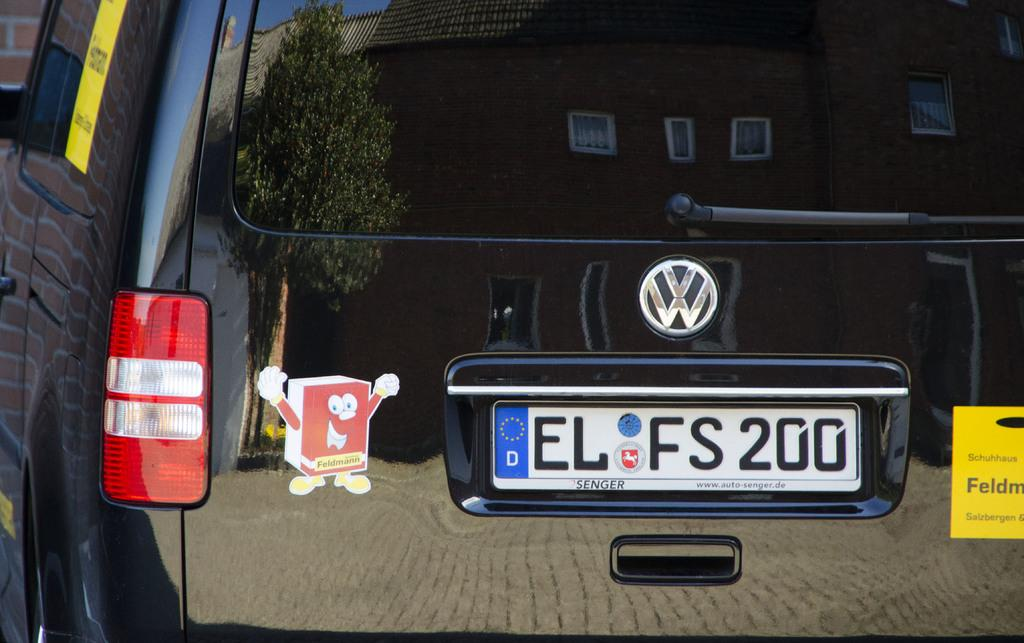<image>
Present a compact description of the photo's key features. A volkswagen branded truck with a vynil sticker of a red book on it. 